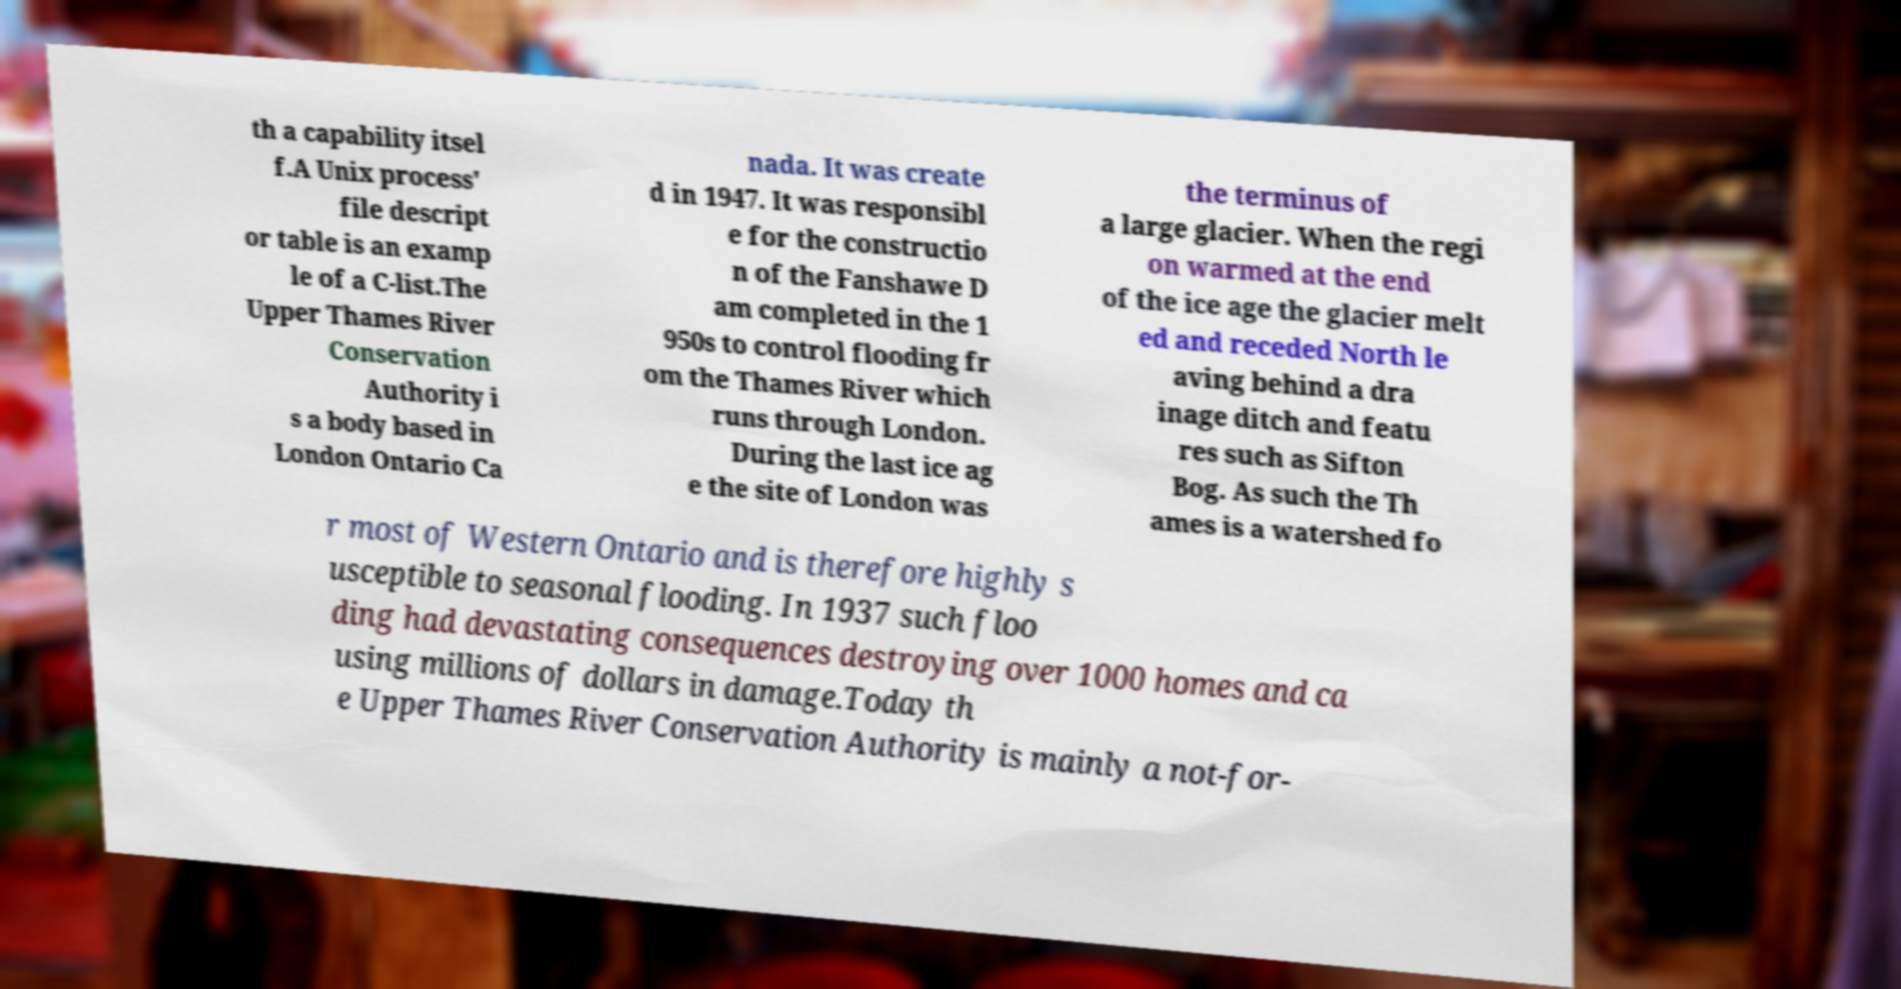For documentation purposes, I need the text within this image transcribed. Could you provide that? th a capability itsel f.A Unix process' file descript or table is an examp le of a C-list.The Upper Thames River Conservation Authority i s a body based in London Ontario Ca nada. It was create d in 1947. It was responsibl e for the constructio n of the Fanshawe D am completed in the 1 950s to control flooding fr om the Thames River which runs through London. During the last ice ag e the site of London was the terminus of a large glacier. When the regi on warmed at the end of the ice age the glacier melt ed and receded North le aving behind a dra inage ditch and featu res such as Sifton Bog. As such the Th ames is a watershed fo r most of Western Ontario and is therefore highly s usceptible to seasonal flooding. In 1937 such floo ding had devastating consequences destroying over 1000 homes and ca using millions of dollars in damage.Today th e Upper Thames River Conservation Authority is mainly a not-for- 